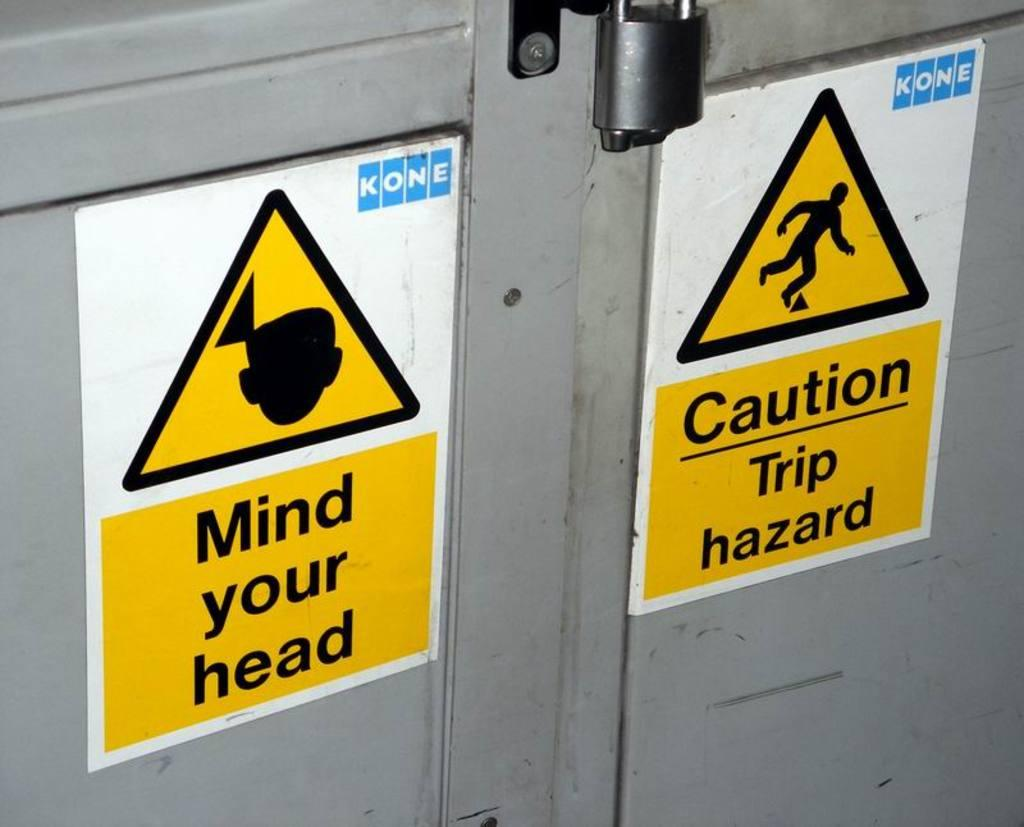<image>
Create a compact narrative representing the image presented. A metal door has a sign that says Mind your head and another sign says Caution Trip hazard. 